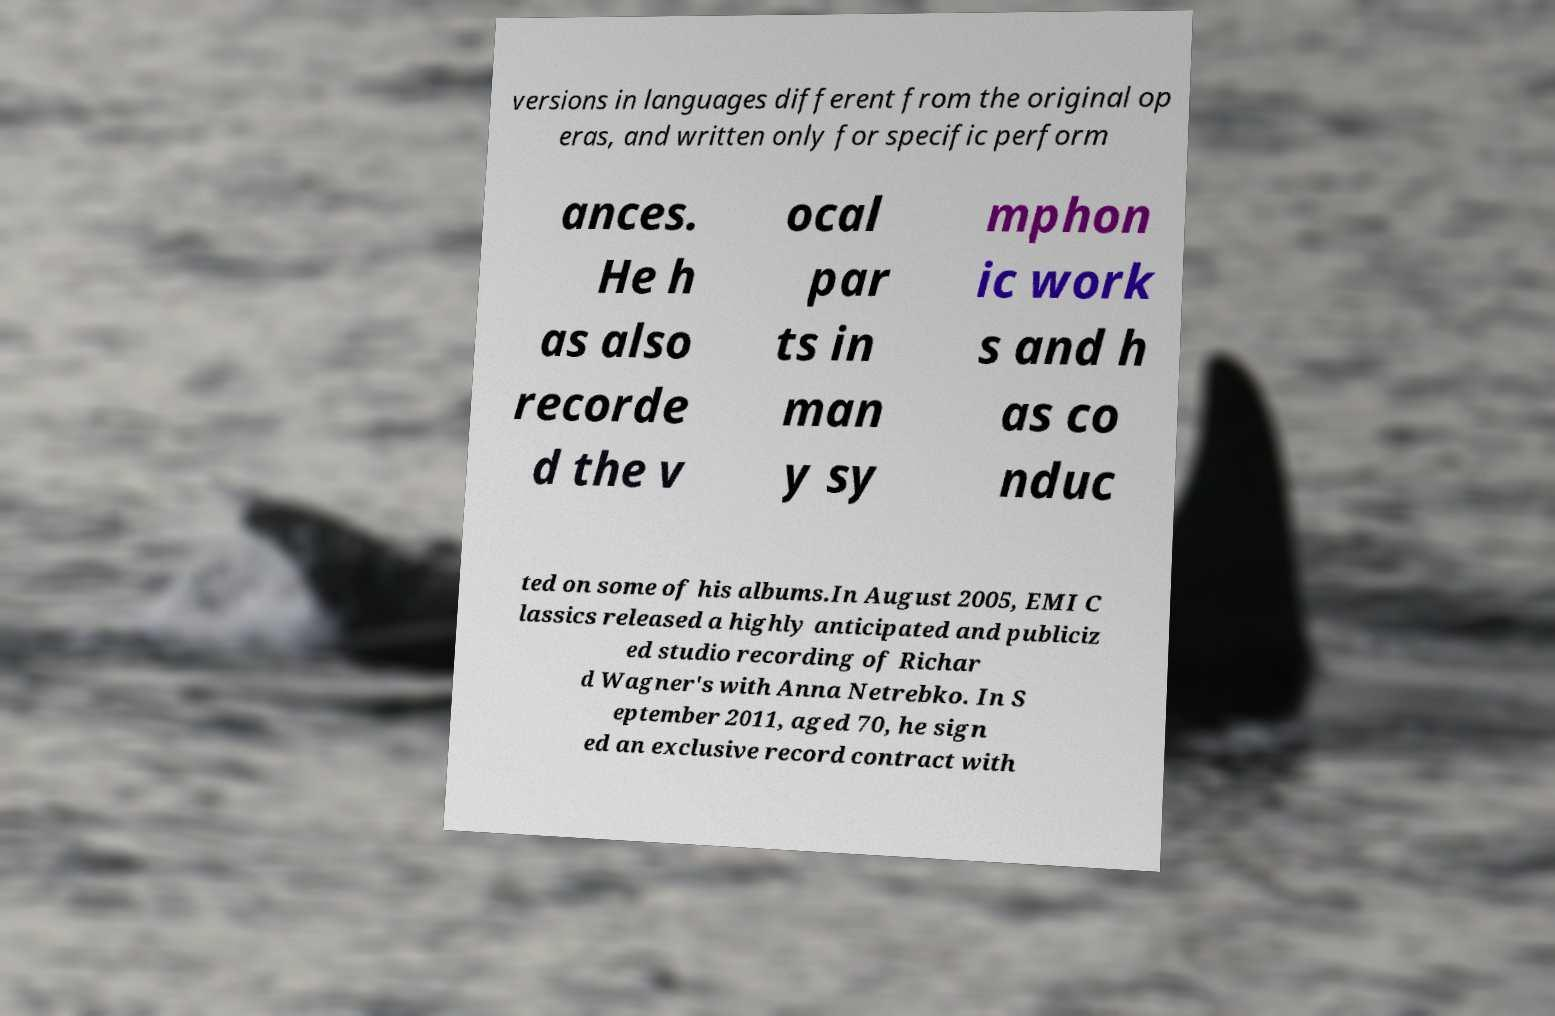Could you assist in decoding the text presented in this image and type it out clearly? versions in languages different from the original op eras, and written only for specific perform ances. He h as also recorde d the v ocal par ts in man y sy mphon ic work s and h as co nduc ted on some of his albums.In August 2005, EMI C lassics released a highly anticipated and publiciz ed studio recording of Richar d Wagner's with Anna Netrebko. In S eptember 2011, aged 70, he sign ed an exclusive record contract with 